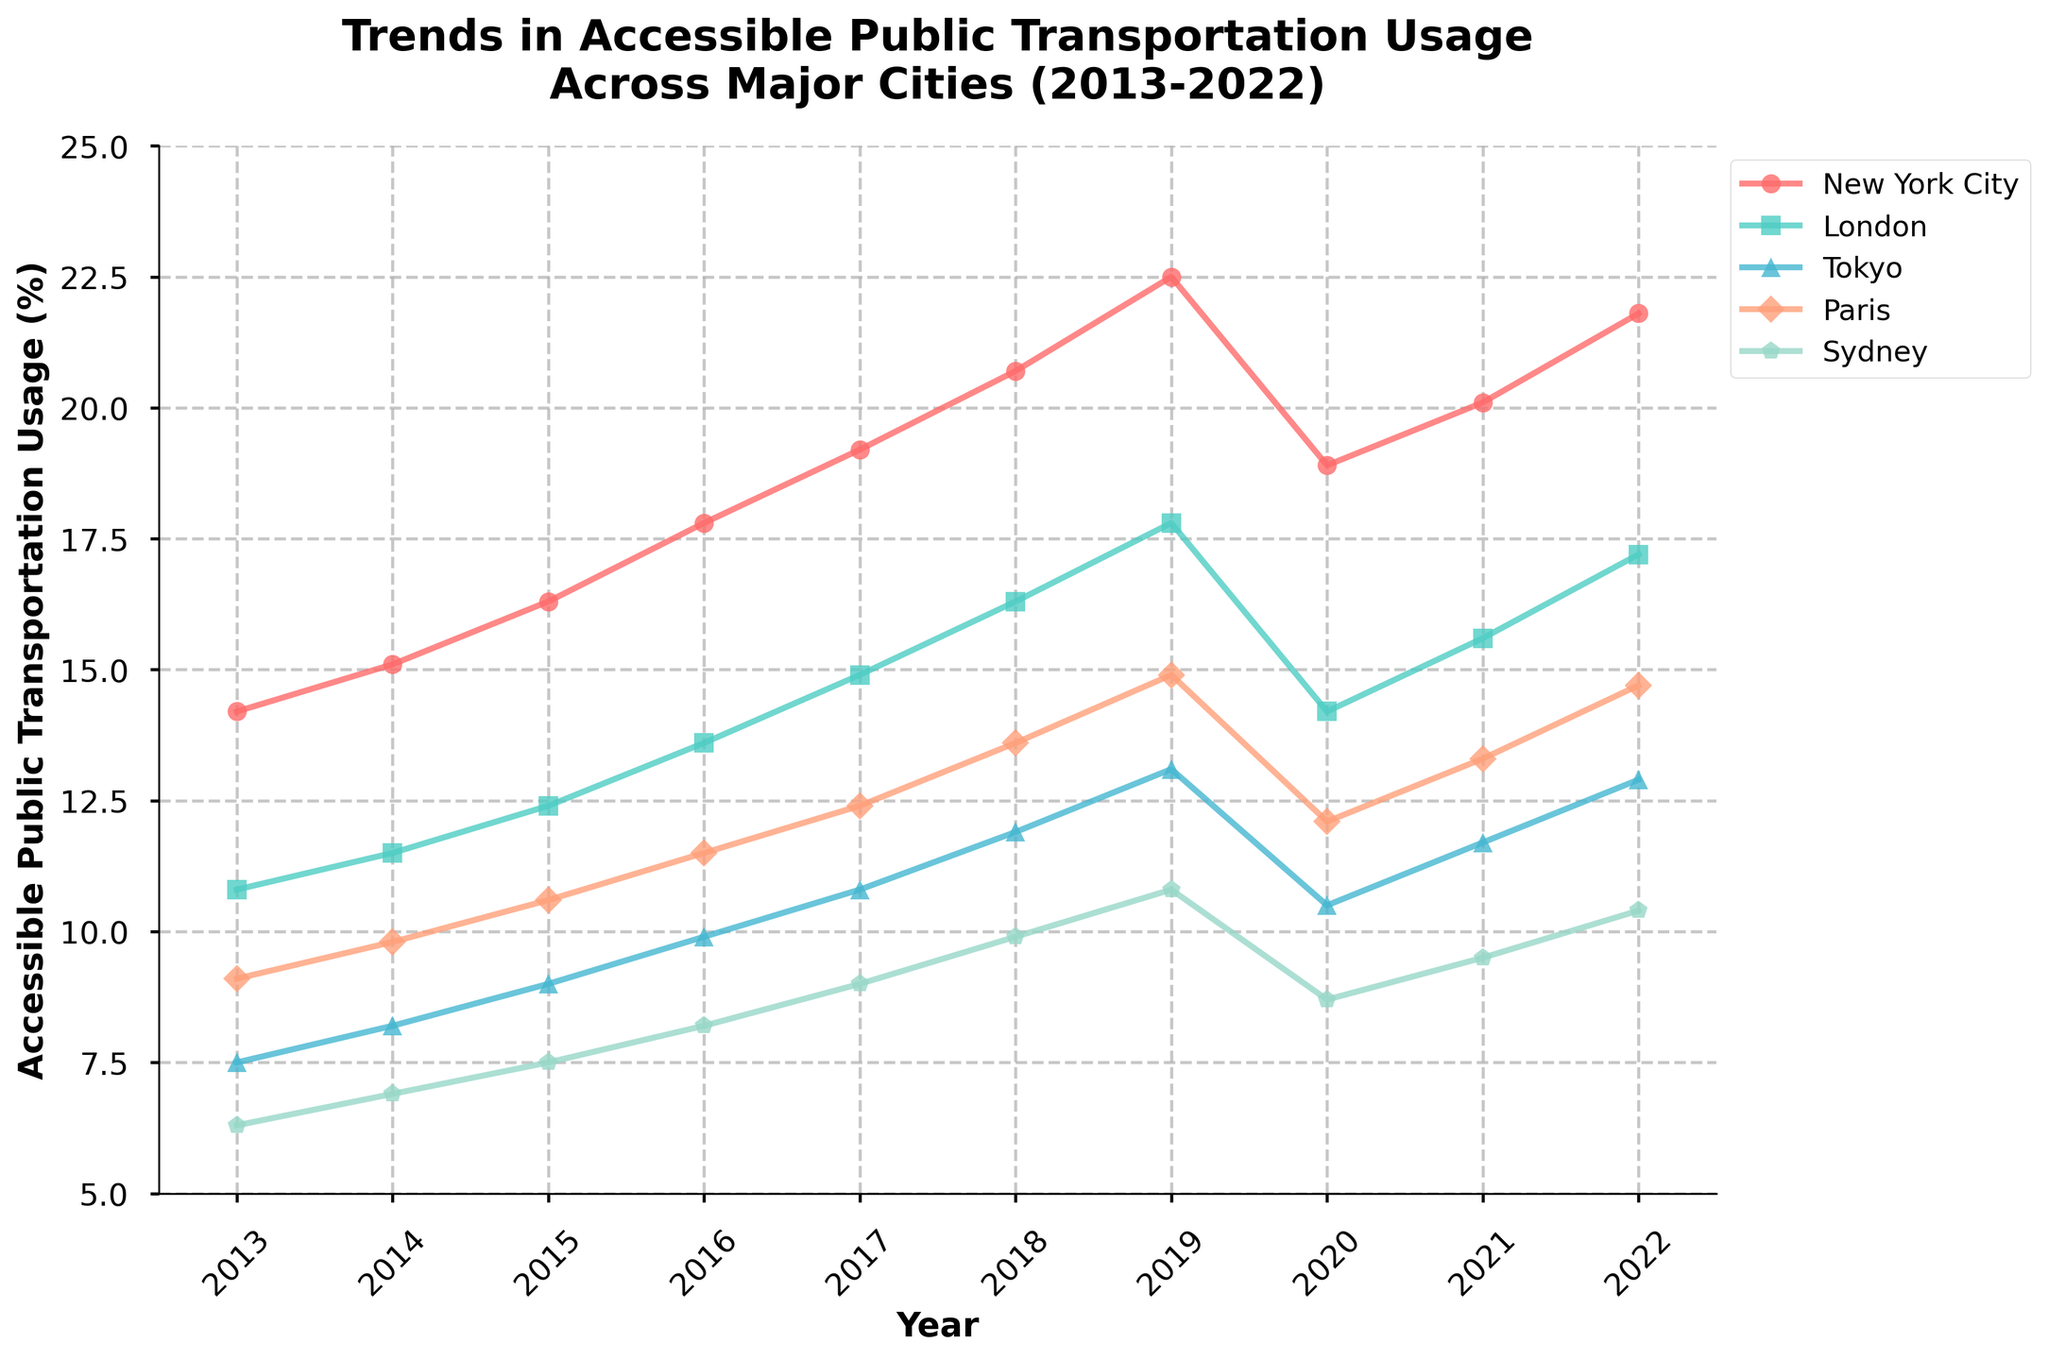What city saw the greatest increase in accessible public transportation usage from 2013 to 2019? To determine this, we find the difference in usage from 2013 to 2019 for all cities. New York City's increase is 22.5 - 14.2 = 8.3, London's is 17.8 - 10.8 = 7.0, Tokyo's is 13.1 - 7.5 = 5.6, Paris's is 14.9 - 9.1 = 5.8, and Sydney's is 10.8 - 6.3 = 4.5. New York City has the greatest increase of 8.3.
Answer: New York City How did the COVID-19 pandemic (2020) affect the usage in Tokyo compared to 2019? To assess the impact, we look at the changes between 2019 and 2020 for Tokyo. In 2019, the usage was 13.1, and in 2020, it dropped to 10.5. The difference is 13.1 - 10.5 = 2.6, showing a decrease.
Answer: Decreased by 2.6 Which city experienced the least fluctuation in accessible public transportation usage over the decade? We evaluate the variance in yearly usage for each city. New York varies between 14.2 to 22.5, London from 10.8 to 17.8, Tokyo from 7.5 to 13.1, Paris from 9.1 to 14.9, and Sydney from 6.3 to 10.8. Sydney has the smallest range, 4.5 (10.8 - 6.3), indicating the least fluctuation.
Answer: Sydney What was the average accessible public transportation usage in Paris from 2013 to 2022? Sum the yearly values for Paris from 2013 to 2022: 9.1 + 9.8 + 10.6 + 11.5 + 12.4 + 13.6 + 14.9 + 12.1 + 13.3 + 14.7 = 122. Then divide by the number of years, 10. The average is 122 / 10 = 12.2.
Answer: 12.2 Did any city have a consistent increase in usage every year from 2013 to 2019? Review the progression for each city. New York, London, Tokyo, Paris, and Sydney all show increasing usage from 2013 to 2019 without any year showing a decrease.
Answer: Yes, all cities Which city recovered the most in accessible public transportation usage from the COVID-19 dip in 2020 to 2021? Calculate the difference in values from 2020 to 2021: New York City (20.1 - 18.9 = 1.2), London (15.6 - 14.2 = 1.4), Tokyo (11.7 - 10.5 = 1.2), Paris (13.3 - 12.1 = 1.2), and Sydney (9.5 - 8.7 = 0.8). London shows the highest recovery of 1.4.
Answer: London In 2022, which two cities had the closest levels of accessible public transportation usage? Compare the 2022 values to determine proximity: New York City (21.8), London (17.2), Tokyo (12.9), Paris (14.7), Sydney (10.4). The closest values are Paris (14.7) and Tokyo (12.9) with a difference of 1.8.
Answer: Paris and Tokyo How does the 2022 usage in Sydney compare to its usage in 2013? Sydney's usage in 2013 was 6.3 and in 2022 was 10.4. The difference is 10.4 - 6.3 = 4.1, indicating an increase.
Answer: Increased by 4.1 What was the overall trend in accessible public transportation usage across all cities from 2013 to 2022? By observing the figure, all cities show an increasing trend overall in accessible transportation usage over the decade, despite the dip in 2020.
Answer: Increasing 